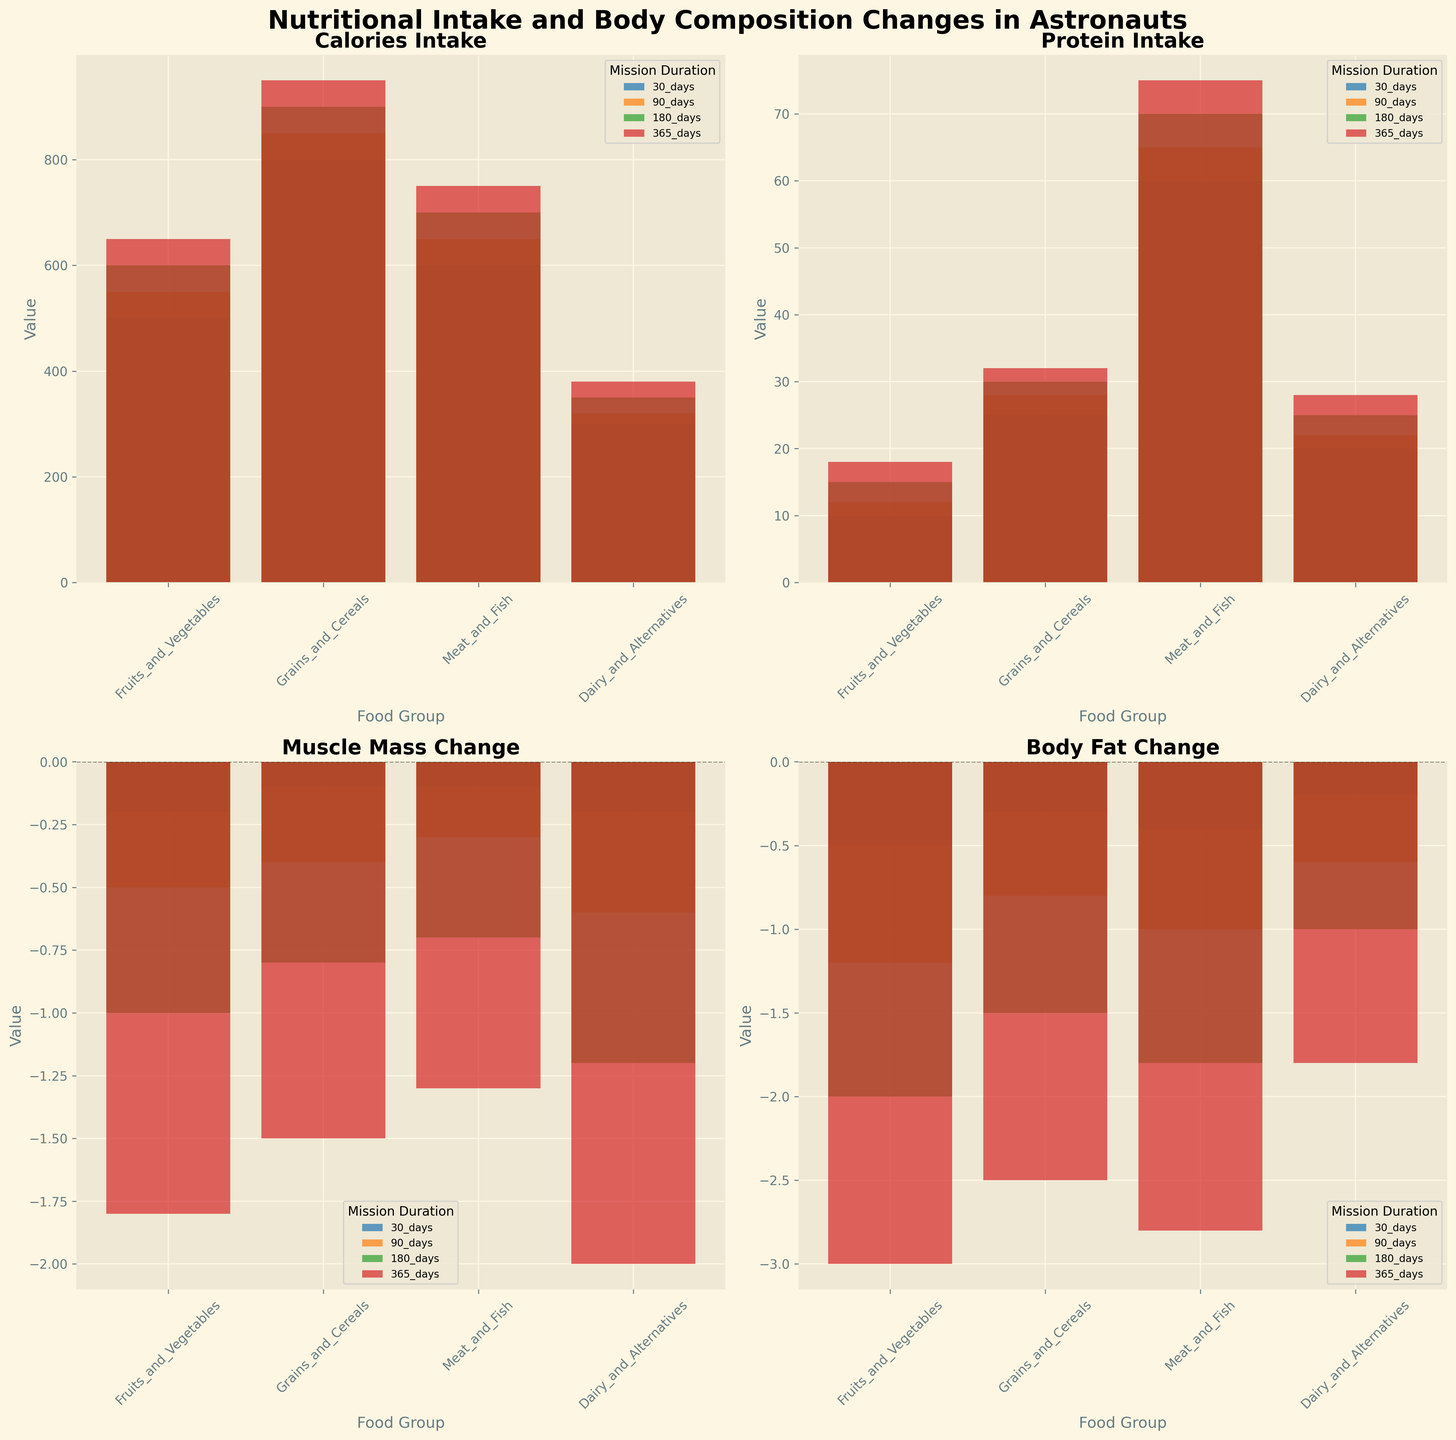What's the average calories intake from 'Meat and Fish' across all mission durations? To find the average, add up the calories intake values for 'Meat and Fish' over all mission durations (30 days, 90 days, 180 days, 365 days) and then divide by the number of durations. Values are: 600, 650, 700, 750. Sum is 2700. Average is 2700/4.
Answer: 675 How do protein intake values for 'Grains and Cereals' compare between 30 days and 365 days? Compare the values by checking the heights of the bars for 'Grains and Cereals' in the ’Protein Intake’ subplot for 30 days (25) and 365 days (32).
Answer: 365 days are higher What is the body fat change for 'Fruits and Vegetables' at 180 days? Find the bar representing 'Fruits and Vegetables' at 180 days in the ‘Body Fat Change’ subplot and check its value, which is indicated to be -2.0.
Answer: -2.0 Which food group has the highest muscle mass change at 90 days? Compare the height of the bars in the ‘Muscle Mass Change’ subplot for the 90-day mission duration. 'Dairy and Alternatives' has a muscle mass change of -0.6, which is the highest among the options.
Answer: Dairy and Alternatives How much does body fat change vary among food groups for a 30-day mission? Check the difference in the heights of bars in the ‘Body Fat Change’ subplot for each food group during the 30-day mission. The changes are: -0.5 (Fruits and Vegetables), -0.3 (Grains and Cereals), -0.4 (Meat and Fish), -0.2 (Dairy and Alternatives).
Answer: Variations from -0.2 to -0.5 What’s the protein intake from 'Dairy and Alternatives' at 30 days and 90 days combined? Add the protein intake values for 'Dairy and Alternatives' during the 30-day (20) and 90-day (22) missions. Sum is 20 + 22.
Answer: 42 Which food group shows the smallest change in body fat over a 365-day mission? In the ‘Body Fat Change’ subplot, the bar with the smallest absolute value for the 365-day mission duration is 'Dairy and Alternatives' with -1.8.
Answer: Dairy and Alternatives How does the calorie intake for 'Fruits and Vegetables' change from 30 days to 365 days? Compare the bar heights for 'Fruits and Vegetables' in the ‘Calories Intake’ subplot for 30 days (500) and 365 days (650).
Answer: Increases by 150 Is there a consistent trend in muscle mass change across all food groups and durations? Assess the ‘Muscle Mass Change’ subplot to see if muscle mass decreases for all food groups across increasing mission durations. All values are negative and tend to decrease over time.
Answer: Yes Who has the highest carb intake in a 180-day mission? Find the tallest bar in the ‘Carb Intake’ subplot for the 180-day mission segment, which corresponds to 'Grains and Cereals' (170).
Answer: Grains and Cereals 